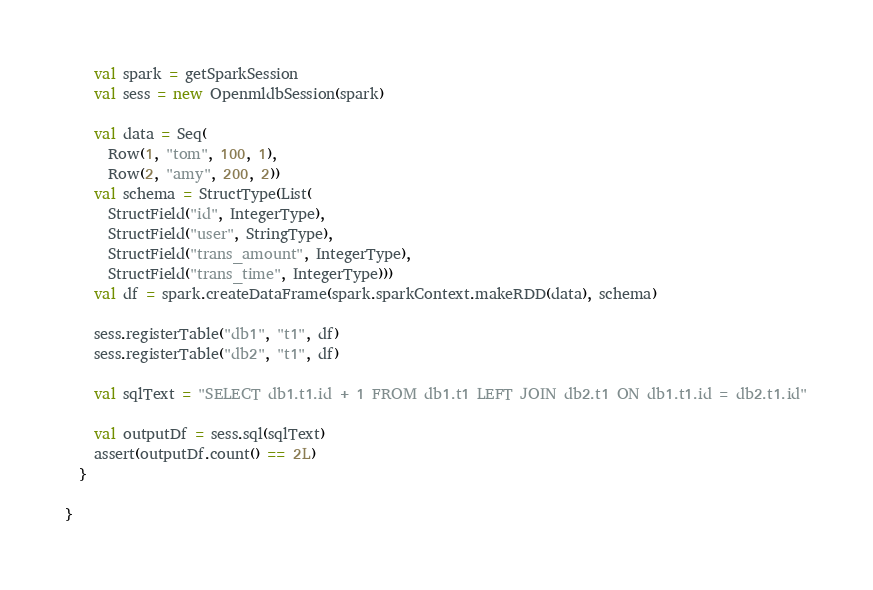<code> <loc_0><loc_0><loc_500><loc_500><_Scala_>    val spark = getSparkSession
    val sess = new OpenmldbSession(spark)

    val data = Seq(
      Row(1, "tom", 100, 1),
      Row(2, "amy", 200, 2))
    val schema = StructType(List(
      StructField("id", IntegerType),
      StructField("user", StringType),
      StructField("trans_amount", IntegerType),
      StructField("trans_time", IntegerType)))
    val df = spark.createDataFrame(spark.sparkContext.makeRDD(data), schema)

    sess.registerTable("db1", "t1", df)
    sess.registerTable("db2", "t1", df)

    val sqlText = "SELECT db1.t1.id + 1 FROM db1.t1 LEFT JOIN db2.t1 ON db1.t1.id = db2.t1.id"

    val outputDf = sess.sql(sqlText)
    assert(outputDf.count() == 2L)
  }

}
</code> 